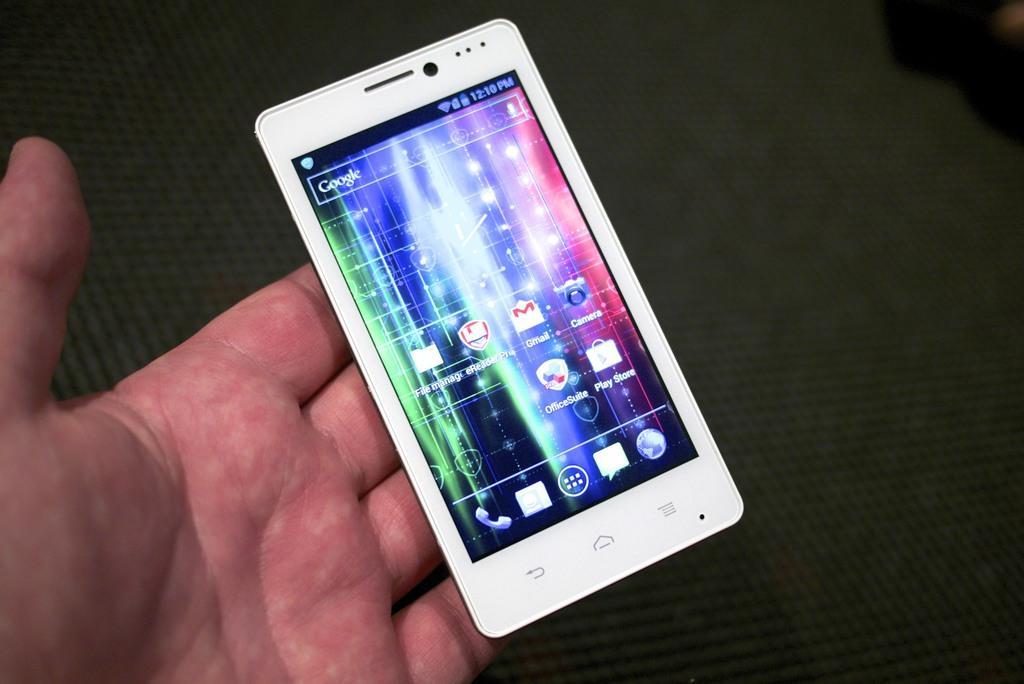Please provide a concise description of this image. This picture contains the hand of the man or the woman holding the mobile phone. In the background, it is black in color. 